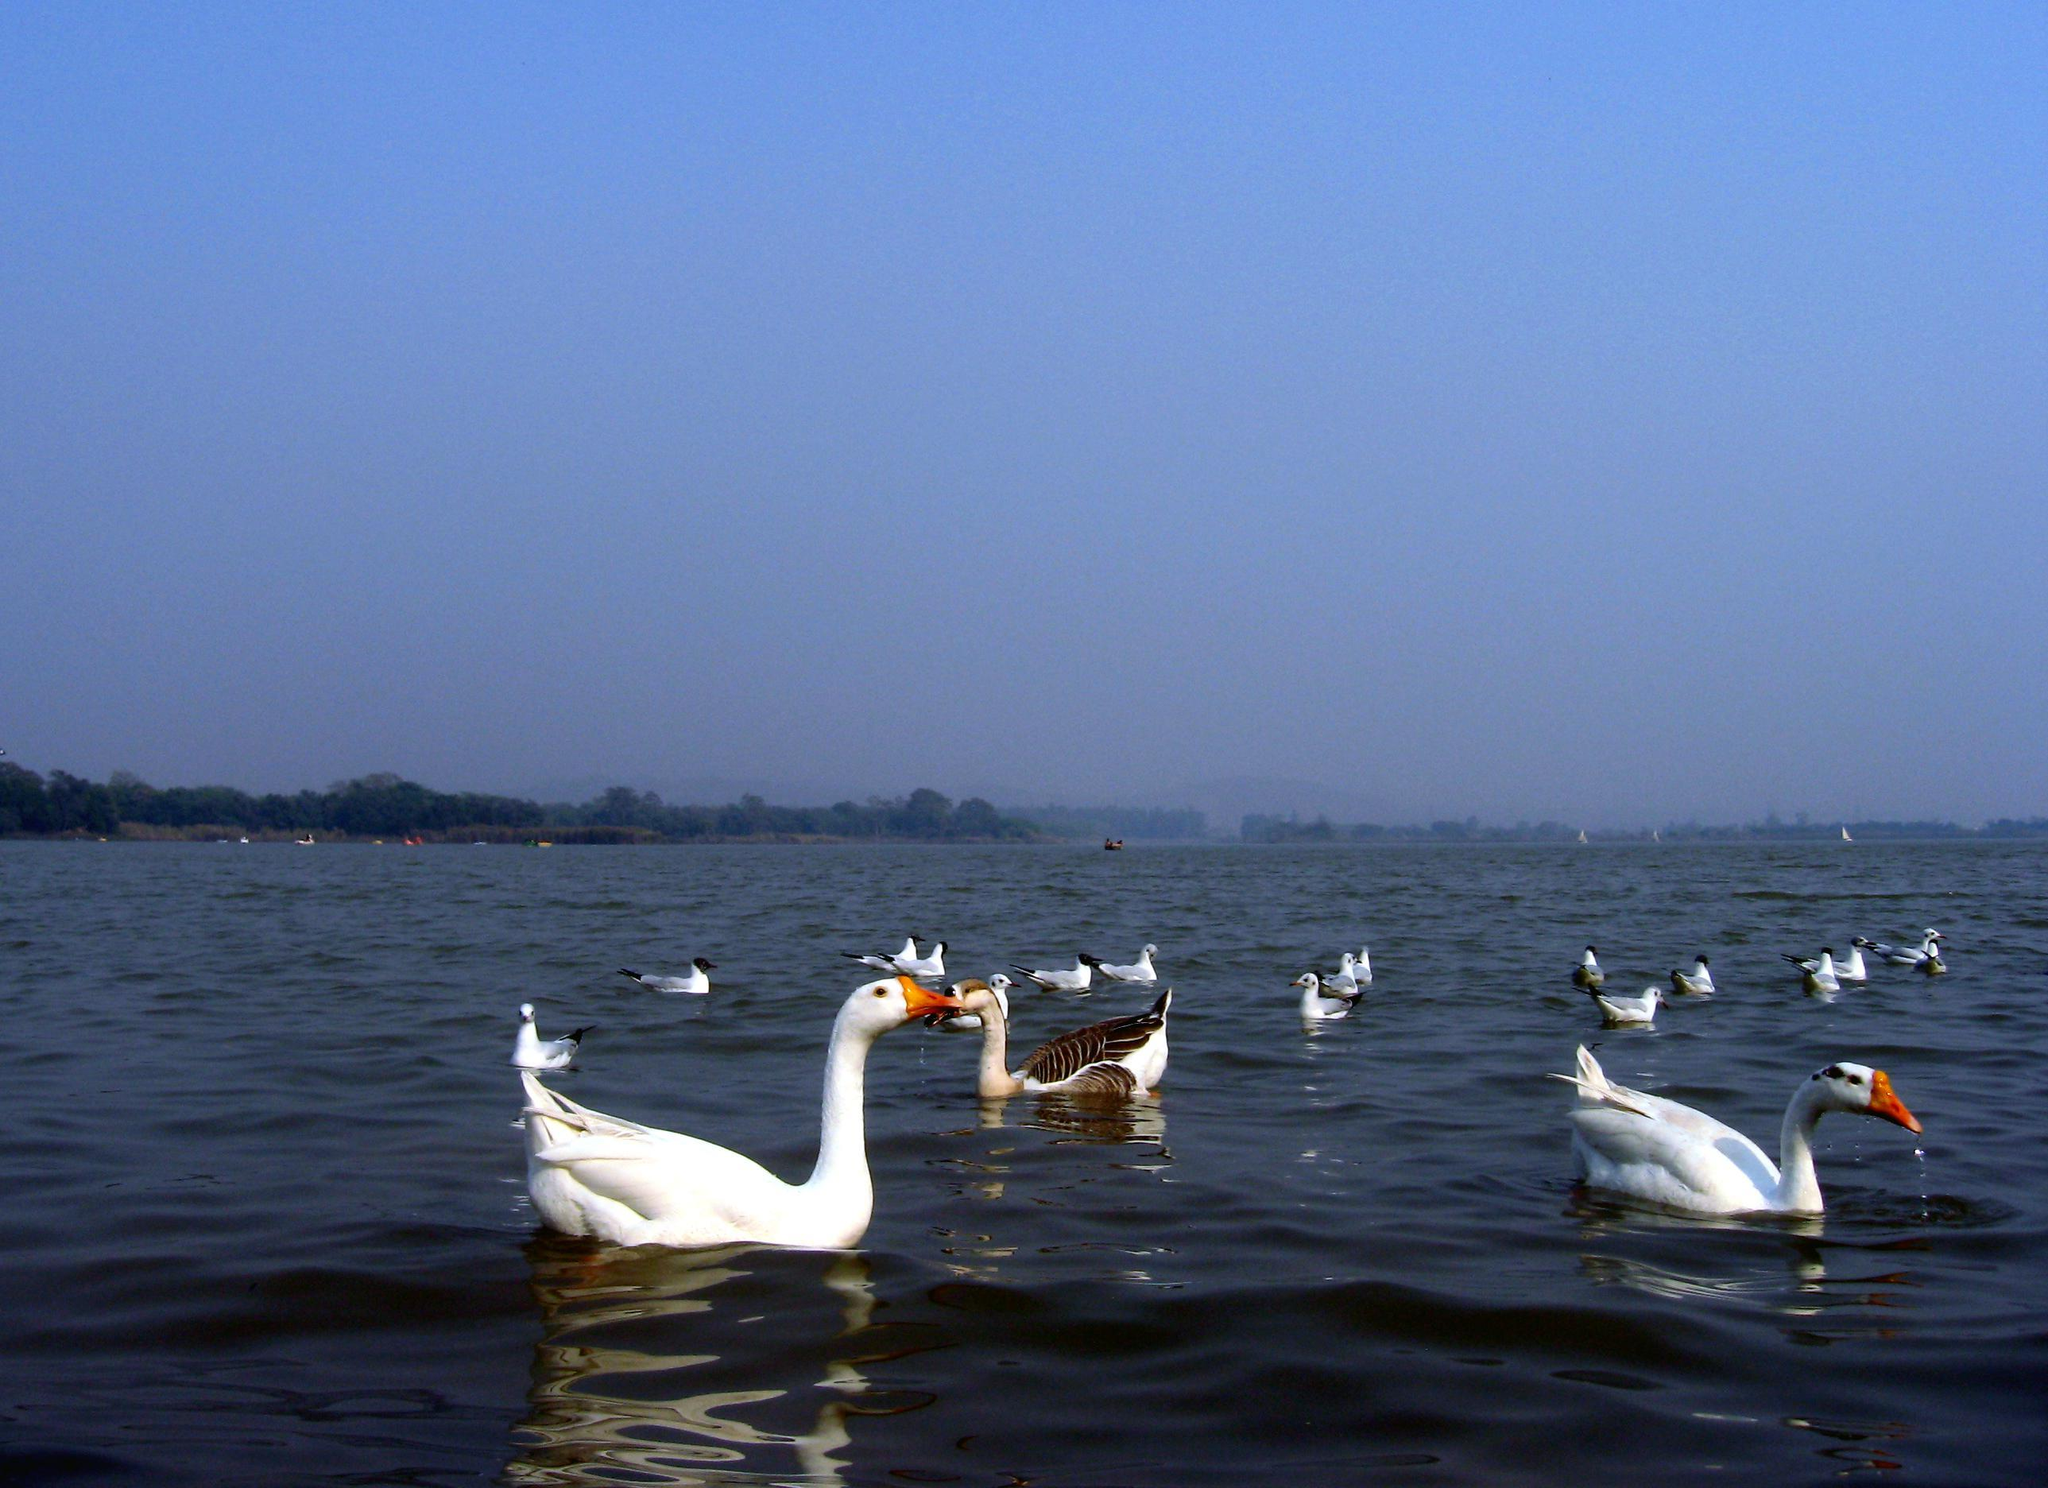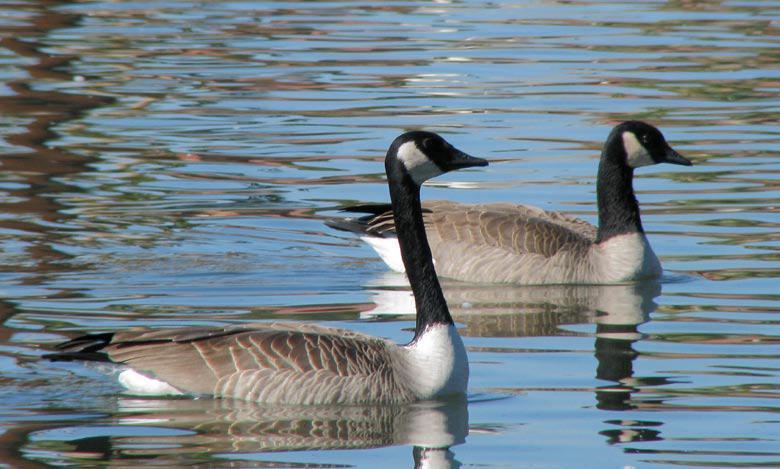The first image is the image on the left, the second image is the image on the right. Examine the images to the left and right. Is the description "The image on the right has no more than one duck and it's body is facing right." accurate? Answer yes or no. No. The first image is the image on the left, the second image is the image on the right. Evaluate the accuracy of this statement regarding the images: "There are two adult Canadian geese floating on water". Is it true? Answer yes or no. No. 